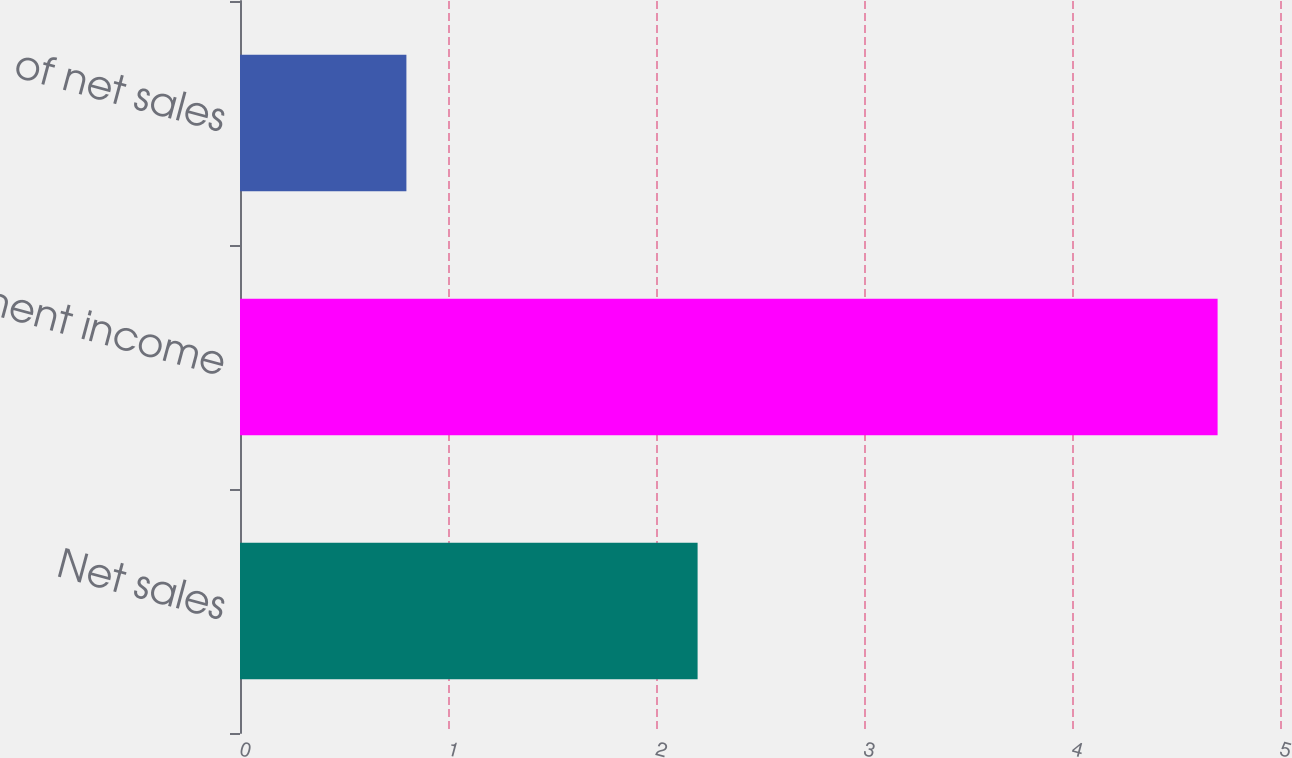Convert chart. <chart><loc_0><loc_0><loc_500><loc_500><bar_chart><fcel>Net sales<fcel>Segment income<fcel>of net sales<nl><fcel>2.2<fcel>4.7<fcel>0.8<nl></chart> 